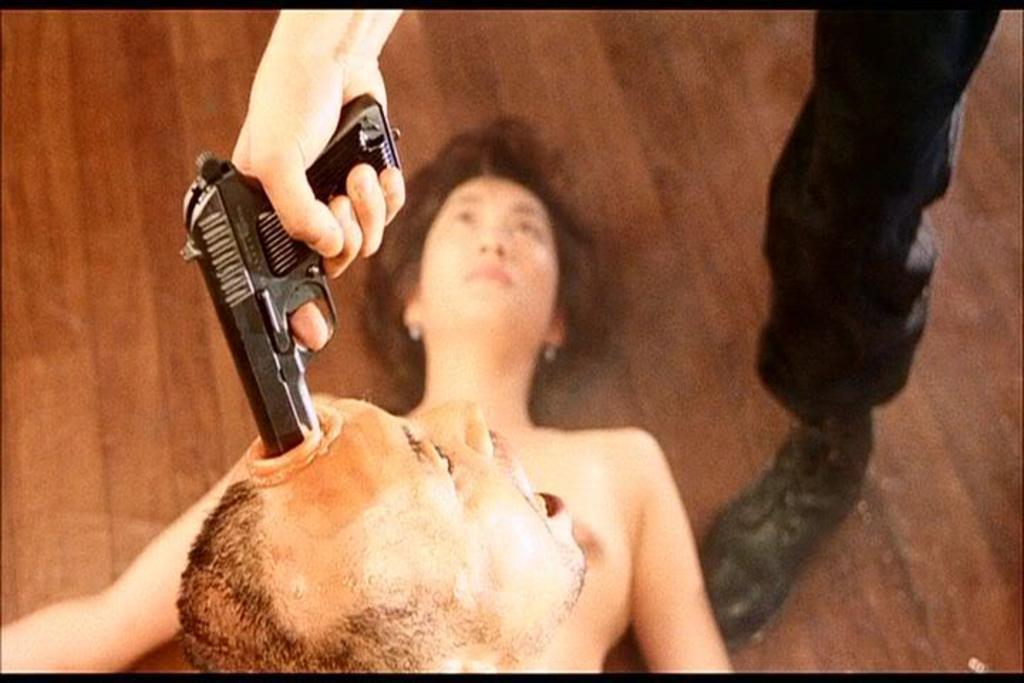In one or two sentences, can you explain what this image depicts? This looks like an edited image. I can see a person's leg and a hand holding a gun. At the bottom of the image, I can see a person's face. Here is another person laying. 